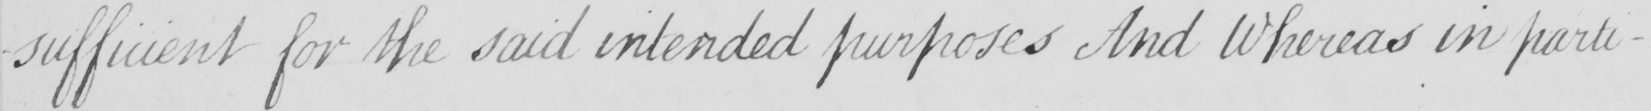What is written in this line of handwriting? for the said intended purposes And Whereas in parti- 